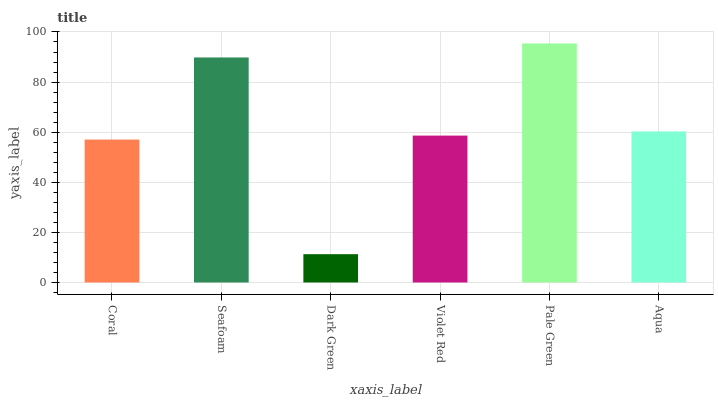Is Dark Green the minimum?
Answer yes or no. Yes. Is Pale Green the maximum?
Answer yes or no. Yes. Is Seafoam the minimum?
Answer yes or no. No. Is Seafoam the maximum?
Answer yes or no. No. Is Seafoam greater than Coral?
Answer yes or no. Yes. Is Coral less than Seafoam?
Answer yes or no. Yes. Is Coral greater than Seafoam?
Answer yes or no. No. Is Seafoam less than Coral?
Answer yes or no. No. Is Aqua the high median?
Answer yes or no. Yes. Is Violet Red the low median?
Answer yes or no. Yes. Is Seafoam the high median?
Answer yes or no. No. Is Pale Green the low median?
Answer yes or no. No. 